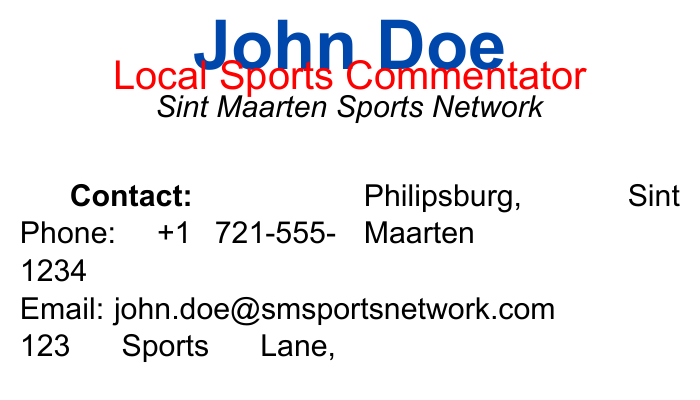what is the name of the commentator? The commentator's name is clearly stated at the top of the document.
Answer: John Doe what is the phone number listed? The phone number is provided in the contact information section.
Answer: +1 721-555-1234 which sport is broadcast on Wednesday? The sport listed for Wednesday's broadcast schedule helps identify what is aired on that day.
Answer: Cricket what channel broadcasts baseball games? The channel information is specified for the respective sports in the broadcasting schedule highlights.
Answer: SM Sports 1 when is football scheduled to air? The broadcasting schedule outlines the specific times and days for each sport.
Answer: Sunday at 1PM how many sports are mentioned in the schedule? Counting the number of scheduled sports gives an overview of the broadcast variety presented.
Answer: Four what social media platform has the username @JohnDoeSports? The username provided indicates which social media platform it is associated with.
Answer: Twitter what is the address listed on the business card? The address is clearly mentioned in the contact section of the document.
Answer: 123 Sports Lane, Philipsburg, Sint Maarten which sport airs on Friday? The schedule highlights reveal what sport is featured on Fridays.
Answer: Baseball 